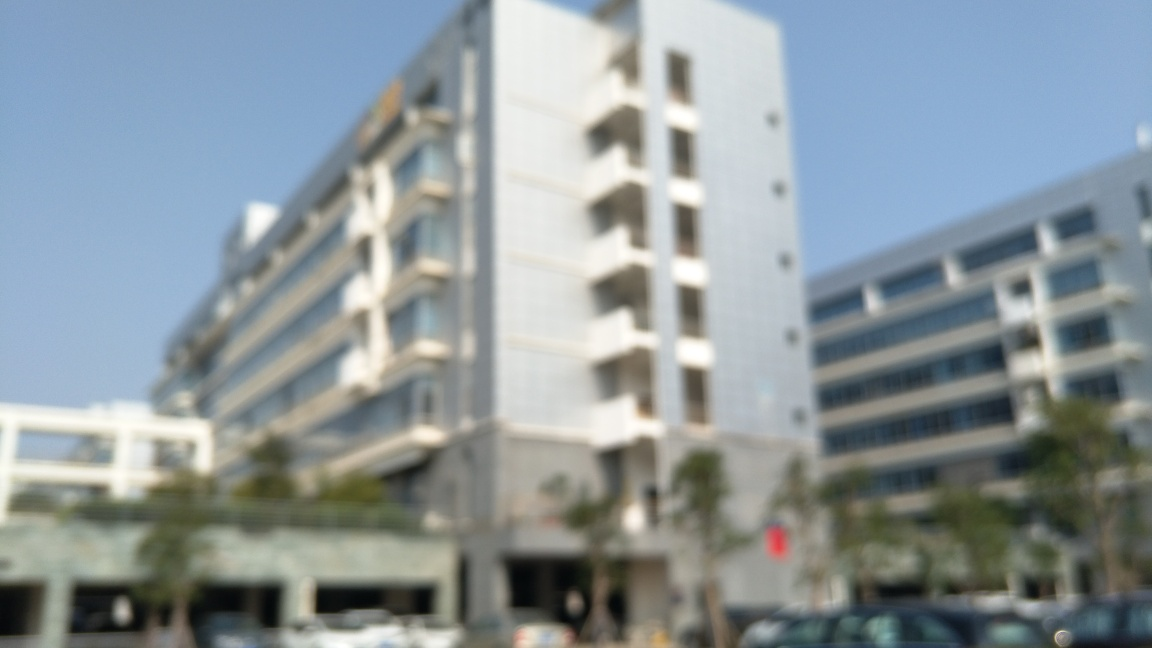What kind of building is shown in this image? Although the image is blurred, it appears to be a modern multi-story building, possibly an office or residential complex, given the architecture and the balconies visible. 